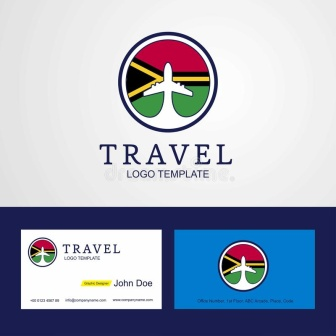How might the design of these business cards impact the company's brand image? The business cards enhance the company's brand image by reflecting a professional yet inviting appearance. The clean, minimalist design with bold colors and clear typography facilitates easy reading and makes a memorable impression. This could help in promoting the company as reliable and sophisticated, which might attract clients looking for quality and dependability in their travel arrangements. Details such as the uncluttered layout, the contact information’s strategic placement, and the use of attractive yet straightforward fonts emphasize accessibility and professionalism. The inclusion of social media details also taps into modern communication trends, aimed at tech-savvy travelers who appreciate convenience and digital connectivity. 